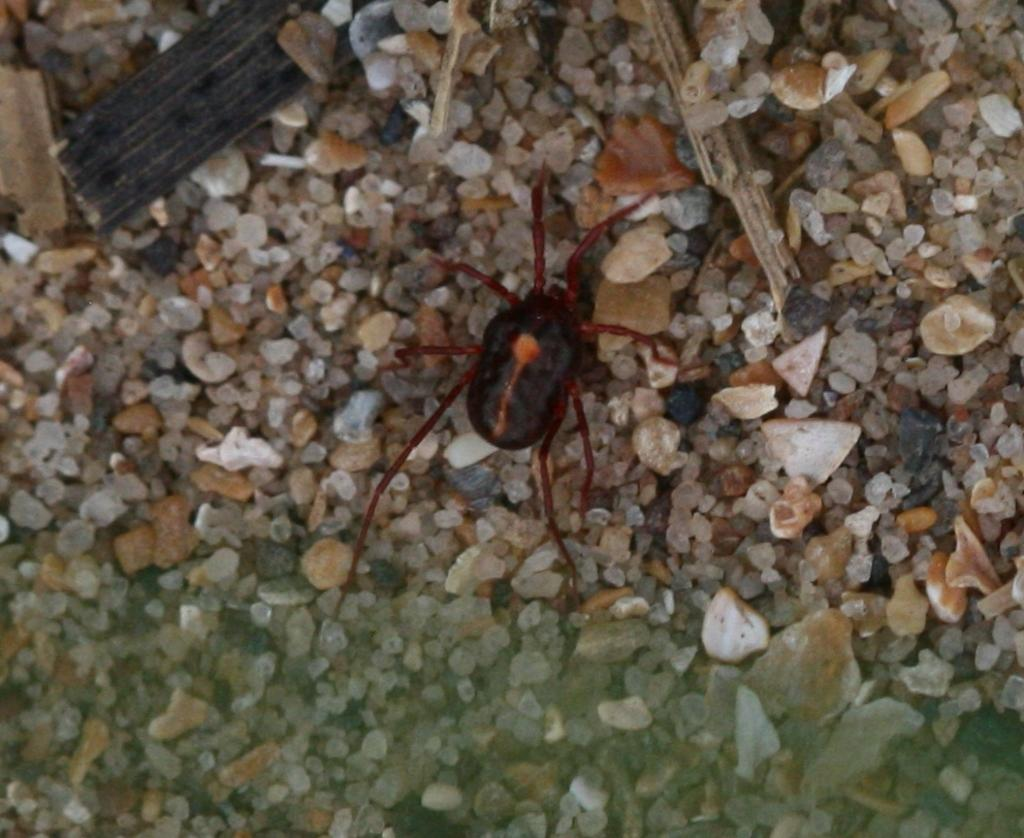What type of material covers the ground in the image? There are small stones on the ground in the image. What objects are made of wood in the image? There are wooden sticks in the image. What type of living creature can be seen in the image? There is an insect in the image. What colors are present on the insect? The insect is black, orange, and red in color. What type of reward is the insect receiving in the image? There is no reward present in the image; it simply shows an insect on the ground with small stones and wooden sticks. Can you tell me how many frogs are visible in the image? There are no frogs present in the image; it features an insect, small stones, and wooden sticks. 